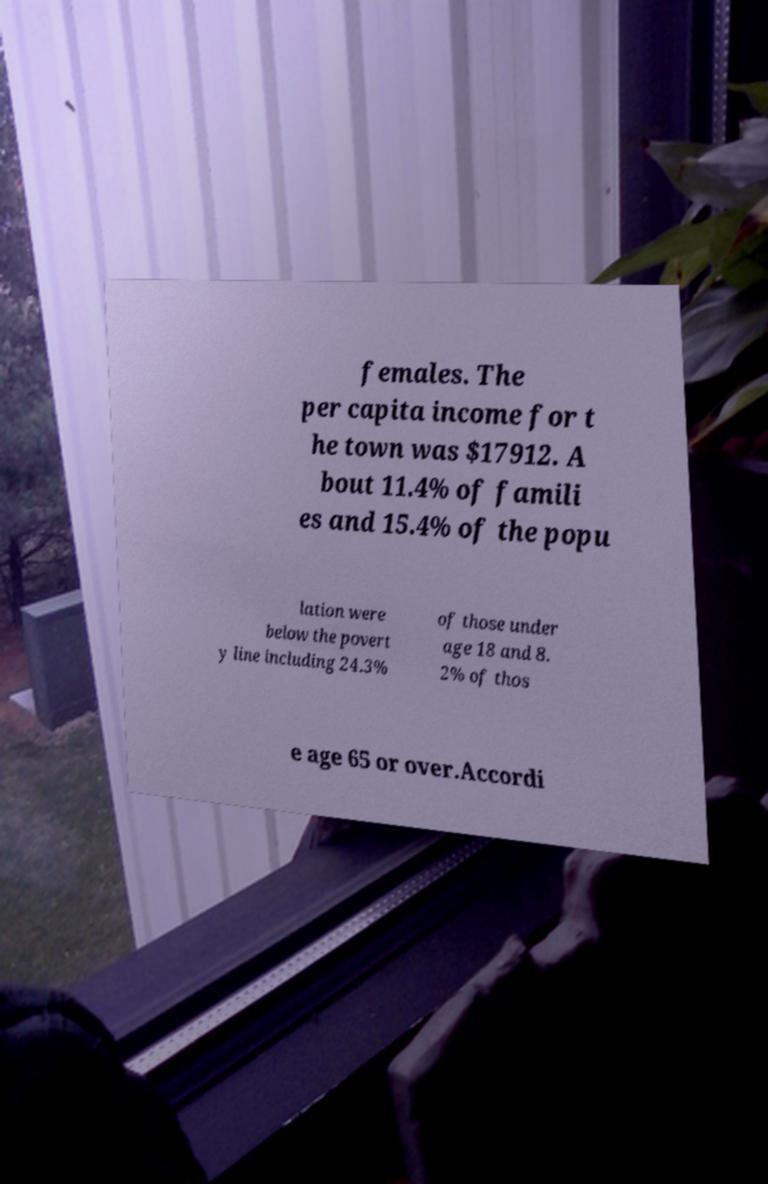Please read and relay the text visible in this image. What does it say? females. The per capita income for t he town was $17912. A bout 11.4% of famili es and 15.4% of the popu lation were below the povert y line including 24.3% of those under age 18 and 8. 2% of thos e age 65 or over.Accordi 